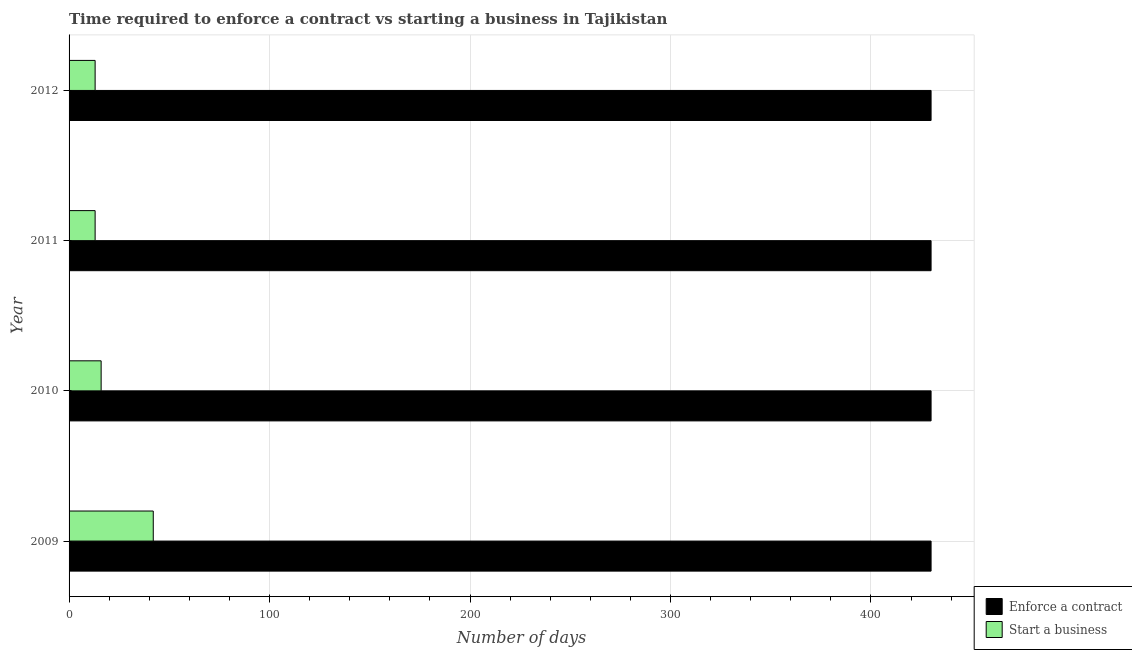How many groups of bars are there?
Offer a very short reply. 4. Are the number of bars per tick equal to the number of legend labels?
Provide a short and direct response. Yes. What is the number of days to enforece a contract in 2009?
Your response must be concise. 430. Across all years, what is the maximum number of days to start a business?
Offer a very short reply. 42. Across all years, what is the minimum number of days to start a business?
Your response must be concise. 13. In which year was the number of days to enforece a contract maximum?
Ensure brevity in your answer.  2009. In which year was the number of days to start a business minimum?
Make the answer very short. 2011. What is the total number of days to start a business in the graph?
Keep it short and to the point. 84. What is the difference between the number of days to start a business in 2009 and that in 2010?
Offer a terse response. 26. What is the difference between the number of days to enforece a contract in 2009 and the number of days to start a business in 2011?
Your answer should be compact. 417. In the year 2012, what is the difference between the number of days to start a business and number of days to enforece a contract?
Keep it short and to the point. -417. In how many years, is the number of days to start a business greater than 360 days?
Make the answer very short. 0. Is the number of days to start a business in 2009 less than that in 2011?
Your response must be concise. No. What is the difference between the highest and the lowest number of days to enforece a contract?
Ensure brevity in your answer.  0. What does the 2nd bar from the top in 2011 represents?
Your answer should be compact. Enforce a contract. What does the 1st bar from the bottom in 2012 represents?
Provide a succinct answer. Enforce a contract. How many bars are there?
Offer a very short reply. 8. How many years are there in the graph?
Your response must be concise. 4. What is the difference between two consecutive major ticks on the X-axis?
Make the answer very short. 100. Are the values on the major ticks of X-axis written in scientific E-notation?
Provide a succinct answer. No. Does the graph contain any zero values?
Offer a terse response. No. Does the graph contain grids?
Your response must be concise. Yes. How are the legend labels stacked?
Make the answer very short. Vertical. What is the title of the graph?
Your answer should be very brief. Time required to enforce a contract vs starting a business in Tajikistan. Does "Investments" appear as one of the legend labels in the graph?
Provide a short and direct response. No. What is the label or title of the X-axis?
Offer a terse response. Number of days. What is the Number of days of Enforce a contract in 2009?
Your answer should be very brief. 430. What is the Number of days in Enforce a contract in 2010?
Your answer should be compact. 430. What is the Number of days in Enforce a contract in 2011?
Keep it short and to the point. 430. What is the Number of days in Enforce a contract in 2012?
Keep it short and to the point. 430. What is the Number of days of Start a business in 2012?
Keep it short and to the point. 13. Across all years, what is the maximum Number of days of Enforce a contract?
Keep it short and to the point. 430. Across all years, what is the minimum Number of days in Enforce a contract?
Offer a terse response. 430. What is the total Number of days in Enforce a contract in the graph?
Provide a succinct answer. 1720. What is the total Number of days of Start a business in the graph?
Offer a very short reply. 84. What is the difference between the Number of days of Enforce a contract in 2009 and that in 2010?
Your response must be concise. 0. What is the difference between the Number of days in Enforce a contract in 2009 and that in 2011?
Provide a short and direct response. 0. What is the difference between the Number of days in Start a business in 2009 and that in 2011?
Provide a short and direct response. 29. What is the difference between the Number of days of Enforce a contract in 2010 and that in 2012?
Give a very brief answer. 0. What is the difference between the Number of days of Start a business in 2010 and that in 2012?
Your answer should be very brief. 3. What is the difference between the Number of days of Enforce a contract in 2011 and that in 2012?
Provide a short and direct response. 0. What is the difference between the Number of days of Enforce a contract in 2009 and the Number of days of Start a business in 2010?
Offer a terse response. 414. What is the difference between the Number of days of Enforce a contract in 2009 and the Number of days of Start a business in 2011?
Give a very brief answer. 417. What is the difference between the Number of days in Enforce a contract in 2009 and the Number of days in Start a business in 2012?
Your answer should be compact. 417. What is the difference between the Number of days in Enforce a contract in 2010 and the Number of days in Start a business in 2011?
Ensure brevity in your answer.  417. What is the difference between the Number of days of Enforce a contract in 2010 and the Number of days of Start a business in 2012?
Offer a very short reply. 417. What is the difference between the Number of days of Enforce a contract in 2011 and the Number of days of Start a business in 2012?
Your answer should be very brief. 417. What is the average Number of days of Enforce a contract per year?
Offer a terse response. 430. What is the average Number of days in Start a business per year?
Offer a terse response. 21. In the year 2009, what is the difference between the Number of days in Enforce a contract and Number of days in Start a business?
Offer a terse response. 388. In the year 2010, what is the difference between the Number of days of Enforce a contract and Number of days of Start a business?
Give a very brief answer. 414. In the year 2011, what is the difference between the Number of days in Enforce a contract and Number of days in Start a business?
Provide a succinct answer. 417. In the year 2012, what is the difference between the Number of days in Enforce a contract and Number of days in Start a business?
Make the answer very short. 417. What is the ratio of the Number of days of Start a business in 2009 to that in 2010?
Make the answer very short. 2.62. What is the ratio of the Number of days in Start a business in 2009 to that in 2011?
Provide a succinct answer. 3.23. What is the ratio of the Number of days in Start a business in 2009 to that in 2012?
Provide a succinct answer. 3.23. What is the ratio of the Number of days in Enforce a contract in 2010 to that in 2011?
Your response must be concise. 1. What is the ratio of the Number of days in Start a business in 2010 to that in 2011?
Offer a terse response. 1.23. What is the ratio of the Number of days in Enforce a contract in 2010 to that in 2012?
Your answer should be compact. 1. What is the ratio of the Number of days of Start a business in 2010 to that in 2012?
Provide a short and direct response. 1.23. What is the difference between the highest and the lowest Number of days in Start a business?
Keep it short and to the point. 29. 